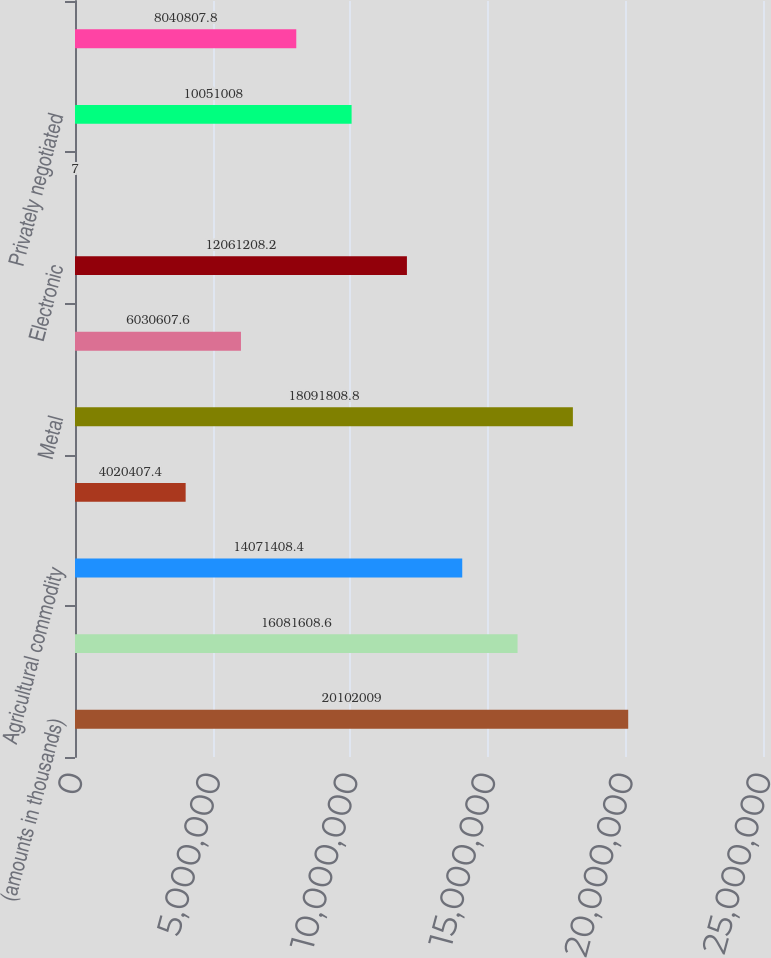Convert chart to OTSL. <chart><loc_0><loc_0><loc_500><loc_500><bar_chart><fcel>(amounts in thousands)<fcel>Interest rate<fcel>Agricultural commodity<fcel>Energy<fcel>Metal<fcel>Aggregate average daily volume<fcel>Electronic<fcel>Open outcry<fcel>Privately negotiated<fcel>Total exchange-traded volume<nl><fcel>2.0102e+07<fcel>1.60816e+07<fcel>1.40714e+07<fcel>4.02041e+06<fcel>1.80918e+07<fcel>6.03061e+06<fcel>1.20612e+07<fcel>7<fcel>1.0051e+07<fcel>8.04081e+06<nl></chart> 